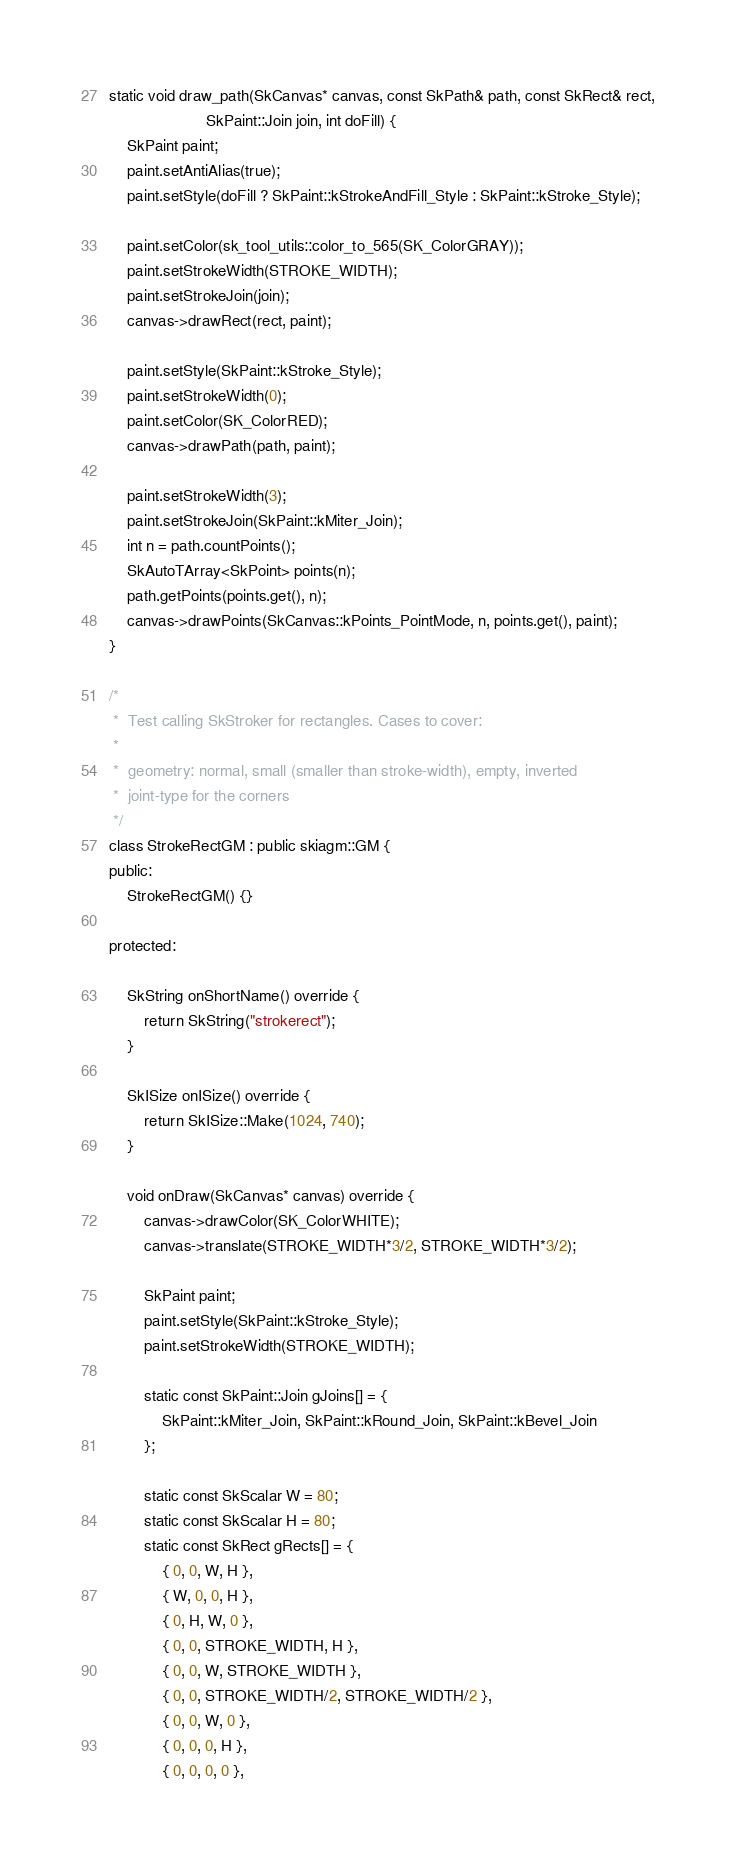Convert code to text. <code><loc_0><loc_0><loc_500><loc_500><_C++_>
static void draw_path(SkCanvas* canvas, const SkPath& path, const SkRect& rect,
                      SkPaint::Join join, int doFill) {
    SkPaint paint;
    paint.setAntiAlias(true);
    paint.setStyle(doFill ? SkPaint::kStrokeAndFill_Style : SkPaint::kStroke_Style);

    paint.setColor(sk_tool_utils::color_to_565(SK_ColorGRAY));
    paint.setStrokeWidth(STROKE_WIDTH);
    paint.setStrokeJoin(join);
    canvas->drawRect(rect, paint);

    paint.setStyle(SkPaint::kStroke_Style);
    paint.setStrokeWidth(0);
    paint.setColor(SK_ColorRED);
    canvas->drawPath(path, paint);

    paint.setStrokeWidth(3);
    paint.setStrokeJoin(SkPaint::kMiter_Join);
    int n = path.countPoints();
    SkAutoTArray<SkPoint> points(n);
    path.getPoints(points.get(), n);
    canvas->drawPoints(SkCanvas::kPoints_PointMode, n, points.get(), paint);
}

/*
 *  Test calling SkStroker for rectangles. Cases to cover:
 *
 *  geometry: normal, small (smaller than stroke-width), empty, inverted
 *  joint-type for the corners
 */
class StrokeRectGM : public skiagm::GM {
public:
    StrokeRectGM() {}

protected:

    SkString onShortName() override {
        return SkString("strokerect");
    }

    SkISize onISize() override {
        return SkISize::Make(1024, 740);
    }

    void onDraw(SkCanvas* canvas) override {
        canvas->drawColor(SK_ColorWHITE);
        canvas->translate(STROKE_WIDTH*3/2, STROKE_WIDTH*3/2);

        SkPaint paint;
        paint.setStyle(SkPaint::kStroke_Style);
        paint.setStrokeWidth(STROKE_WIDTH);

        static const SkPaint::Join gJoins[] = {
            SkPaint::kMiter_Join, SkPaint::kRound_Join, SkPaint::kBevel_Join
        };

        static const SkScalar W = 80;
        static const SkScalar H = 80;
        static const SkRect gRects[] = {
            { 0, 0, W, H },
            { W, 0, 0, H },
            { 0, H, W, 0 },
            { 0, 0, STROKE_WIDTH, H },
            { 0, 0, W, STROKE_WIDTH },
            { 0, 0, STROKE_WIDTH/2, STROKE_WIDTH/2 },
            { 0, 0, W, 0 },
            { 0, 0, 0, H },
            { 0, 0, 0, 0 },</code> 